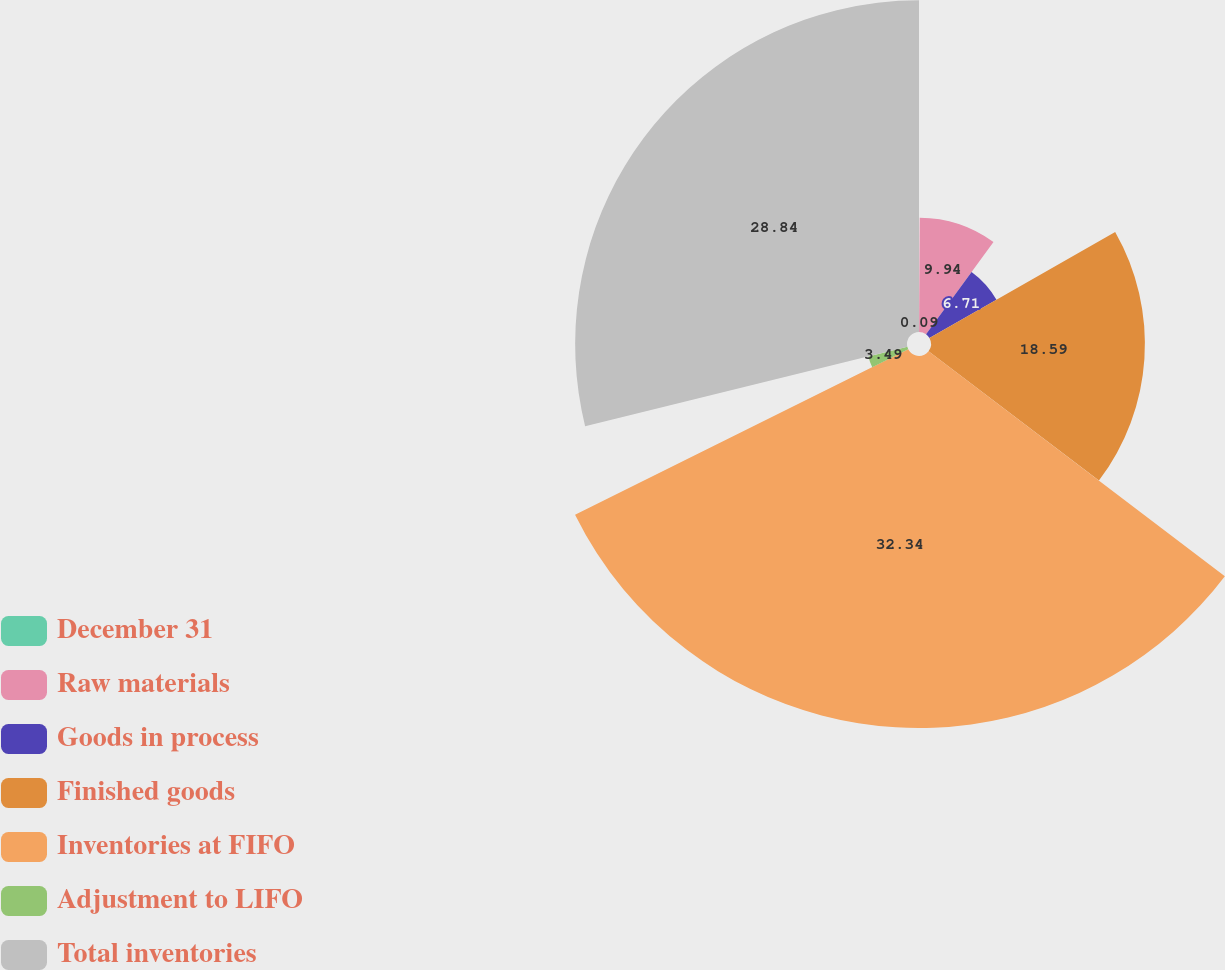<chart> <loc_0><loc_0><loc_500><loc_500><pie_chart><fcel>December 31<fcel>Raw materials<fcel>Goods in process<fcel>Finished goods<fcel>Inventories at FIFO<fcel>Adjustment to LIFO<fcel>Total inventories<nl><fcel>0.09%<fcel>9.94%<fcel>6.71%<fcel>18.59%<fcel>32.33%<fcel>3.49%<fcel>28.84%<nl></chart> 